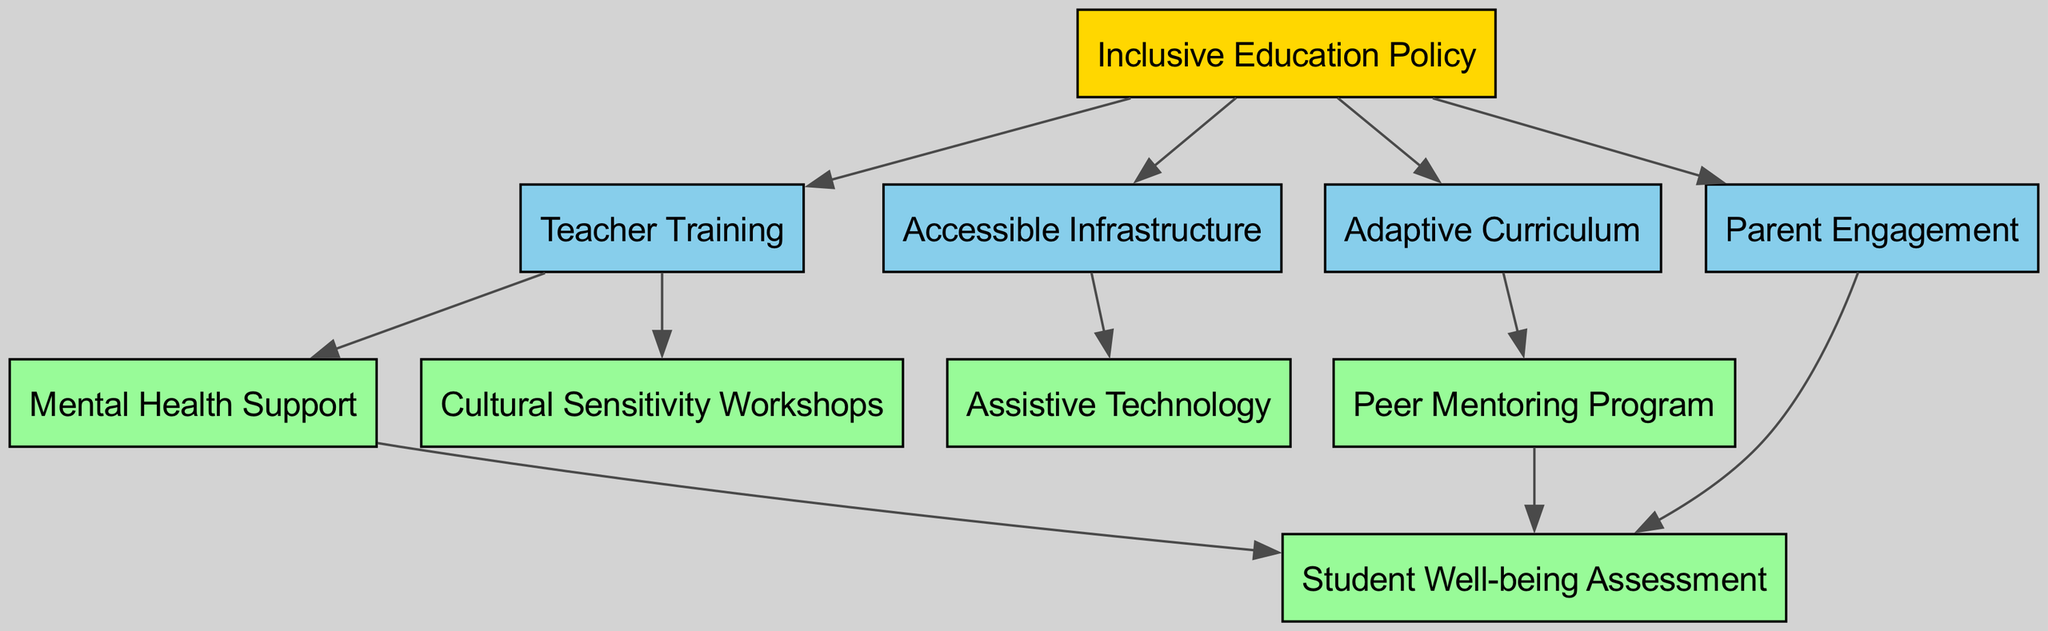What are the main initiatives outlined in this diagram? The nodes represent the main initiatives in the hierarchy, which include "Inclusive Education Policy," "Teacher Training," "Accessible Infrastructure," "Adaptive Curriculum," "Mental Health Support," "Peer Mentoring Program," "Parent Engagement," "Assistive Technology," "Cultural Sensitivity Workshops," and "Student Well-being Assessment."
Answer: Inclusive Education Policy, Teacher Training, Accessible Infrastructure, Adaptive Curriculum, Mental Health Support, Peer Mentoring Program, Parent Engagement, Assistive Technology, Cultural Sensitivity Workshops, Student Well-being Assessment How many nodes are in the diagram? The total number of unique initiatives (nodes) listed in the diagram is counted. There are ten distinct nodes.
Answer: 10 Which node has the most outgoing edges? By examining the outgoing connections, the node "Inclusive Education Policy" has outgoing edges to four other nodes. This indicates that it is a primary focus for several other initiatives.
Answer: Inclusive Education Policy What's the relationship between "Teacher Training" and "Mental Health Support"? The diagram shows a directed edge from "Teacher Training" to "Mental Health Support," indicating that Teacher Training is a precursor or a necessary element that leads to the implementation of Mental Health Support.
Answer: Teacher Training leads to Mental Health Support Which initiative directly connects to the "Student Well-being Assessment"? The edges leading to "Student Well-being Assessment" stem from three different nodes: "Mental Health Support," "Peer Mentoring Program," and "Parent Engagement." Each of these initiatives contributes to or supports the assessment of student well-being.
Answer: Mental Health Support, Peer Mentoring Program, Parent Engagement How many edges are in the graph? Counting the directed connections (edges) between the nodes provides the total number of edges. There are ten edges in total represented in the diagram.
Answer: 10 What does the "Accessible Infrastructure" node connect to? There is a direct edge from "Accessible Infrastructure" to "Assistive Technology," indicating that improvements in infrastructure support the use of assistive technology in the school setting.
Answer: Assistive Technology Which initiatives are influenced by "Adaptive Curriculum"? The diagram indicates that "Adaptive Curriculum" leads to one other node, which is "Peer Mentoring Program." This shows the direct impact of adapting curricula on peer mentoring efforts.
Answer: Peer Mentoring Program What is the input for "Cultural Sensitivity Workshops"? The incoming edge to "Cultural Sensitivity Workshops" shows that it is influenced by "Teacher Training." Therefore, teacher training is necessary to provide cultural sensitivity workshops.
Answer: Teacher Training 